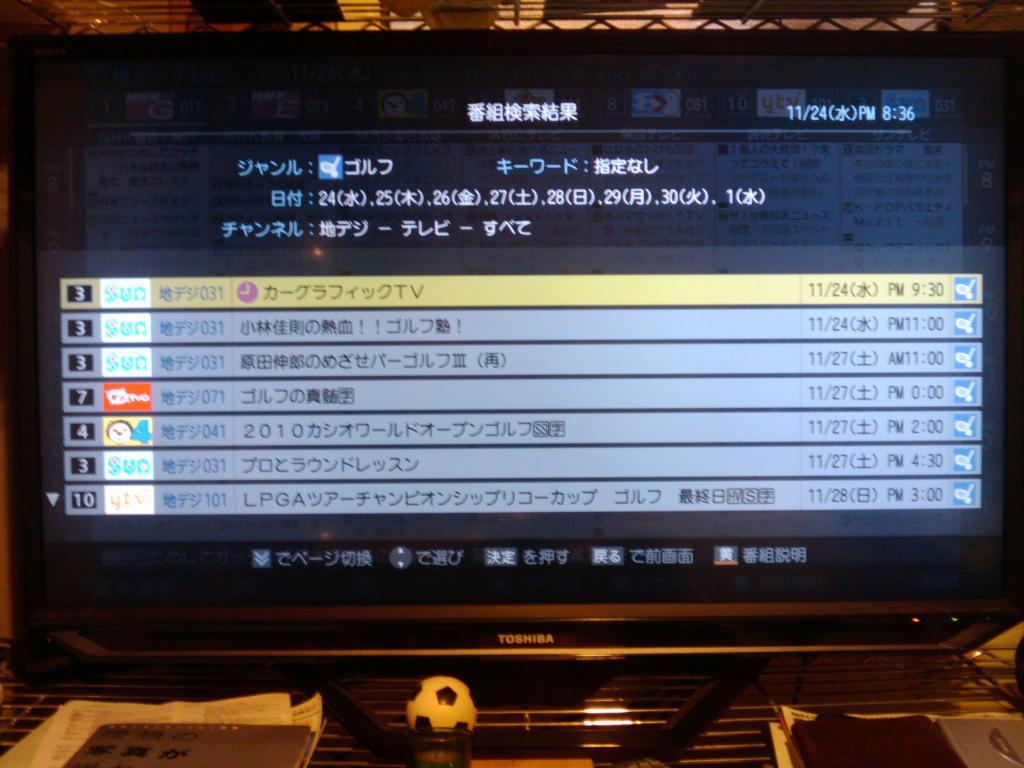<image>
Give a short and clear explanation of the subsequent image. a menu that has a lot of Japanese writing 